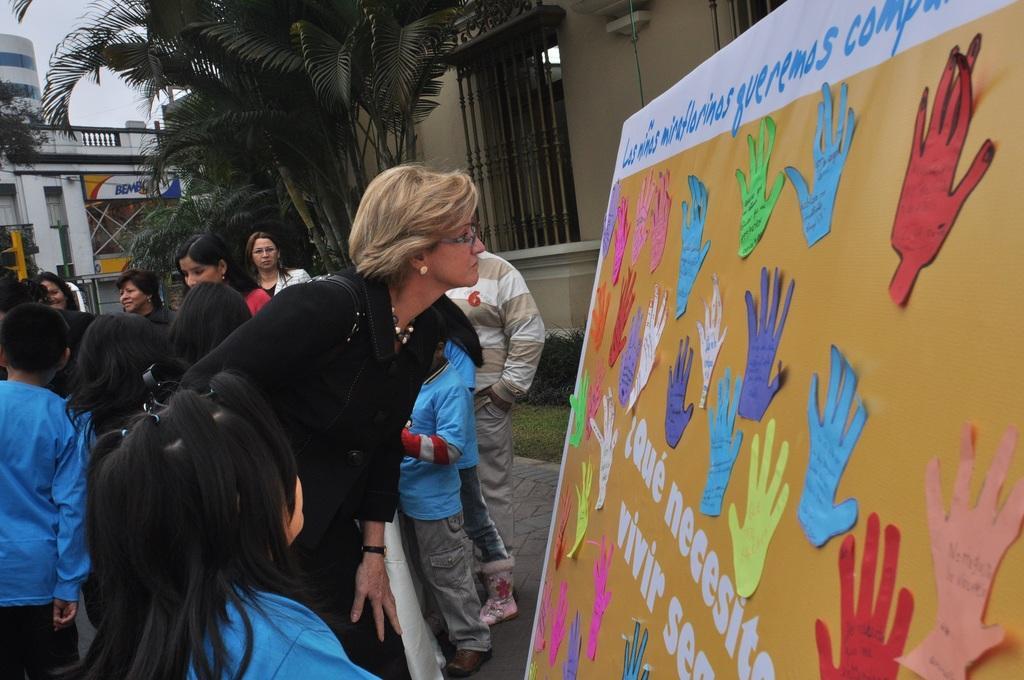Could you give a brief overview of what you see in this image? On the left side of the image we can see a few people are standing. On the right side of the image, we can see one board. On the board, we can see notes and some text. In the background, we can see the sky, trees, buildings, one banner, plants, grass and a few other objects. 